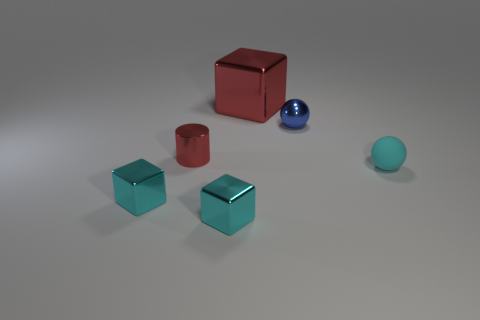Subtract all small cyan blocks. How many blocks are left? 1 Add 3 blue rubber things. How many objects exist? 9 Subtract all red spheres. How many cyan cubes are left? 2 Subtract all balls. How many objects are left? 4 Subtract all gray cylinders. Subtract all gray blocks. How many cylinders are left? 1 Subtract all balls. Subtract all tiny gray matte blocks. How many objects are left? 4 Add 4 shiny spheres. How many shiny spheres are left? 5 Add 6 red things. How many red things exist? 8 Subtract 1 cyan spheres. How many objects are left? 5 Subtract 1 cylinders. How many cylinders are left? 0 